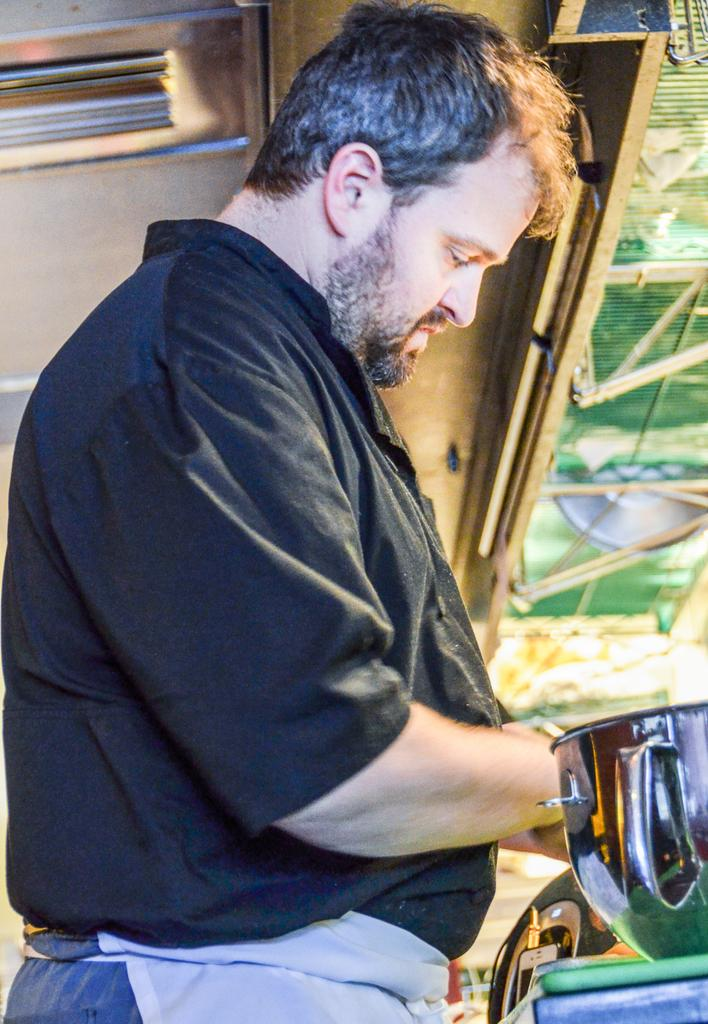Who is present in the image? There is a man in the image. What is the man wearing? The man is wearing a black shirt. What object is in front of the man? There is a bowl in front of the man. What type of rose can be seen growing out of the bowl in the image? There is no rose present in the image; it features a man wearing a black shirt with a bowl in front of him. 